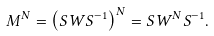Convert formula to latex. <formula><loc_0><loc_0><loc_500><loc_500>M ^ { N } = \left ( S W S ^ { - 1 } \right ) ^ { N } = S W ^ { N } S ^ { - 1 } .</formula> 